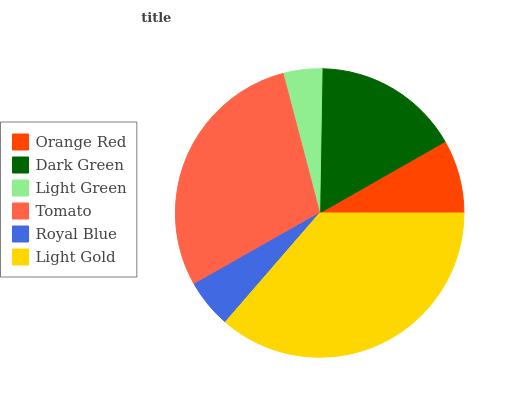Is Light Green the minimum?
Answer yes or no. Yes. Is Light Gold the maximum?
Answer yes or no. Yes. Is Dark Green the minimum?
Answer yes or no. No. Is Dark Green the maximum?
Answer yes or no. No. Is Dark Green greater than Orange Red?
Answer yes or no. Yes. Is Orange Red less than Dark Green?
Answer yes or no. Yes. Is Orange Red greater than Dark Green?
Answer yes or no. No. Is Dark Green less than Orange Red?
Answer yes or no. No. Is Dark Green the high median?
Answer yes or no. Yes. Is Orange Red the low median?
Answer yes or no. Yes. Is Royal Blue the high median?
Answer yes or no. No. Is Tomato the low median?
Answer yes or no. No. 